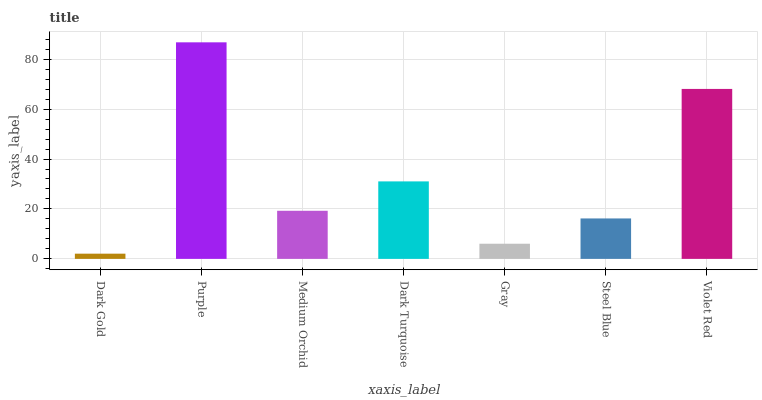Is Dark Gold the minimum?
Answer yes or no. Yes. Is Purple the maximum?
Answer yes or no. Yes. Is Medium Orchid the minimum?
Answer yes or no. No. Is Medium Orchid the maximum?
Answer yes or no. No. Is Purple greater than Medium Orchid?
Answer yes or no. Yes. Is Medium Orchid less than Purple?
Answer yes or no. Yes. Is Medium Orchid greater than Purple?
Answer yes or no. No. Is Purple less than Medium Orchid?
Answer yes or no. No. Is Medium Orchid the high median?
Answer yes or no. Yes. Is Medium Orchid the low median?
Answer yes or no. Yes. Is Purple the high median?
Answer yes or no. No. Is Violet Red the low median?
Answer yes or no. No. 